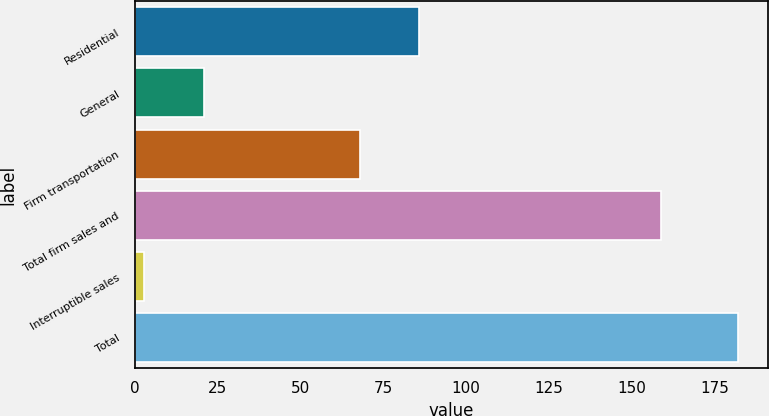Convert chart. <chart><loc_0><loc_0><loc_500><loc_500><bar_chart><fcel>Residential<fcel>General<fcel>Firm transportation<fcel>Total firm sales and<fcel>Interruptible sales<fcel>Total<nl><fcel>85.9<fcel>20.9<fcel>68<fcel>159<fcel>3<fcel>182<nl></chart> 